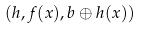<formula> <loc_0><loc_0><loc_500><loc_500>( h , f ( x ) , b \oplus h ( x ) )</formula> 